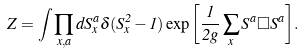Convert formula to latex. <formula><loc_0><loc_0><loc_500><loc_500>Z = \int \prod _ { x , a } d S ^ { a } _ { x } \delta ( S ^ { 2 } _ { x } - 1 ) \exp { \left [ \frac { 1 } { 2 g } \sum _ { x } S ^ { a } \Box S ^ { a } \right ] } .</formula> 